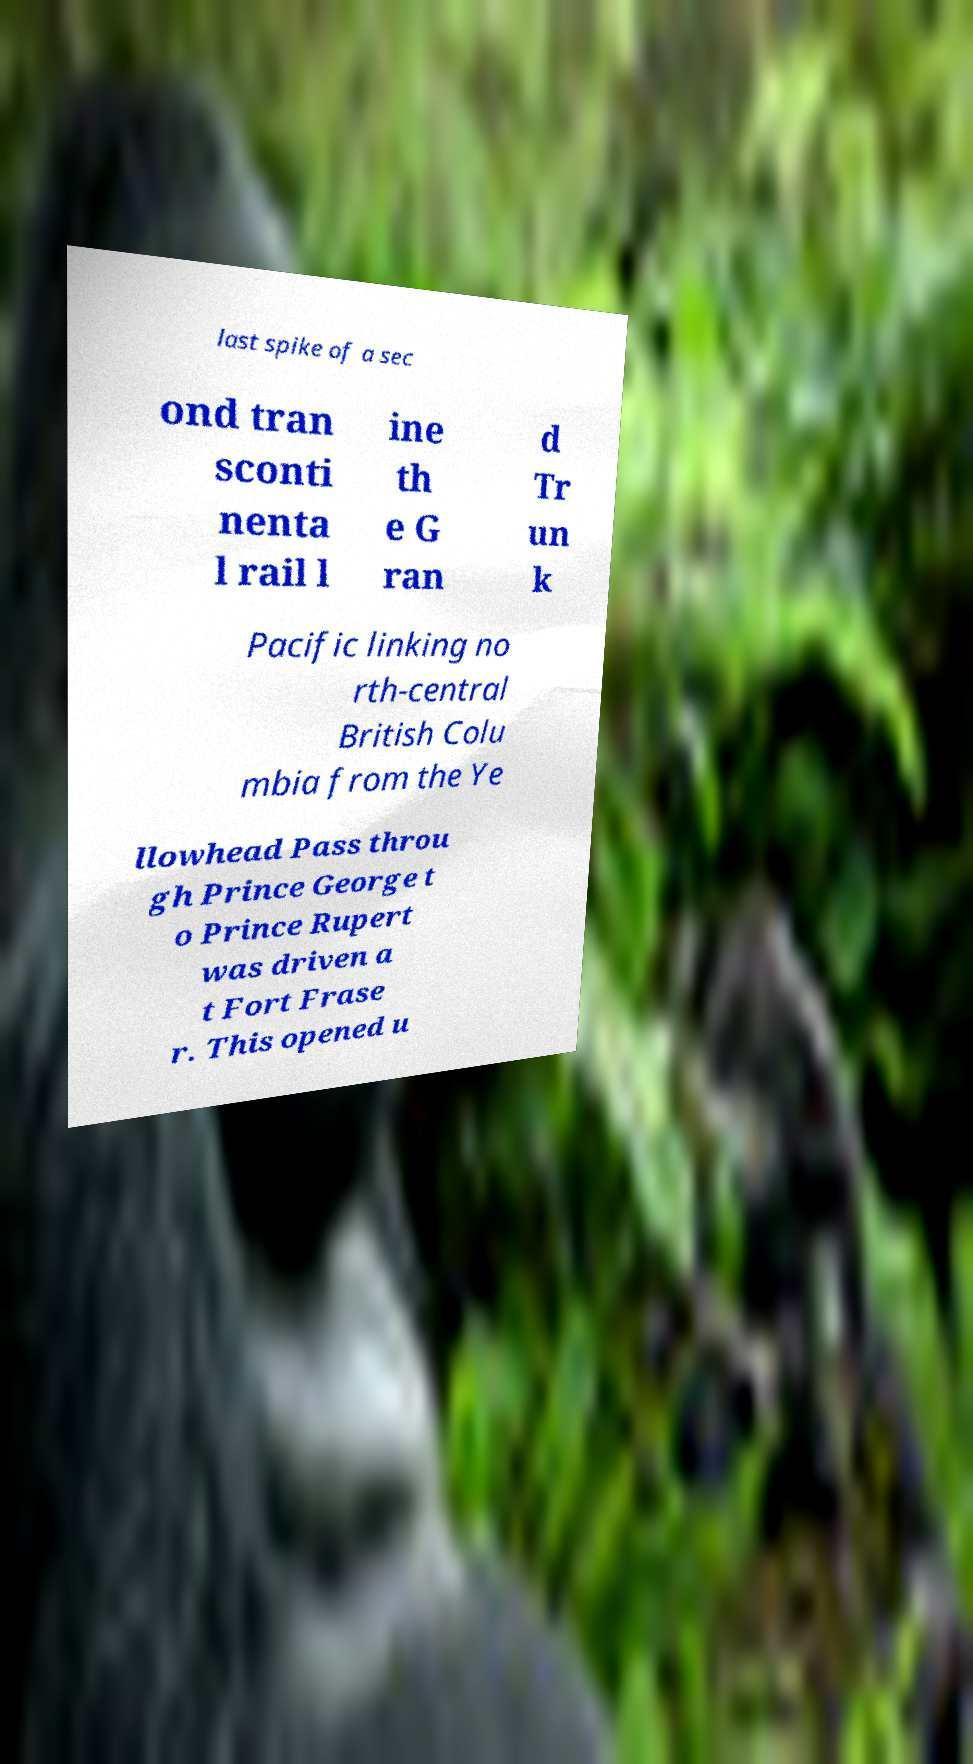There's text embedded in this image that I need extracted. Can you transcribe it verbatim? last spike of a sec ond tran sconti nenta l rail l ine th e G ran d Tr un k Pacific linking no rth-central British Colu mbia from the Ye llowhead Pass throu gh Prince George t o Prince Rupert was driven a t Fort Frase r. This opened u 